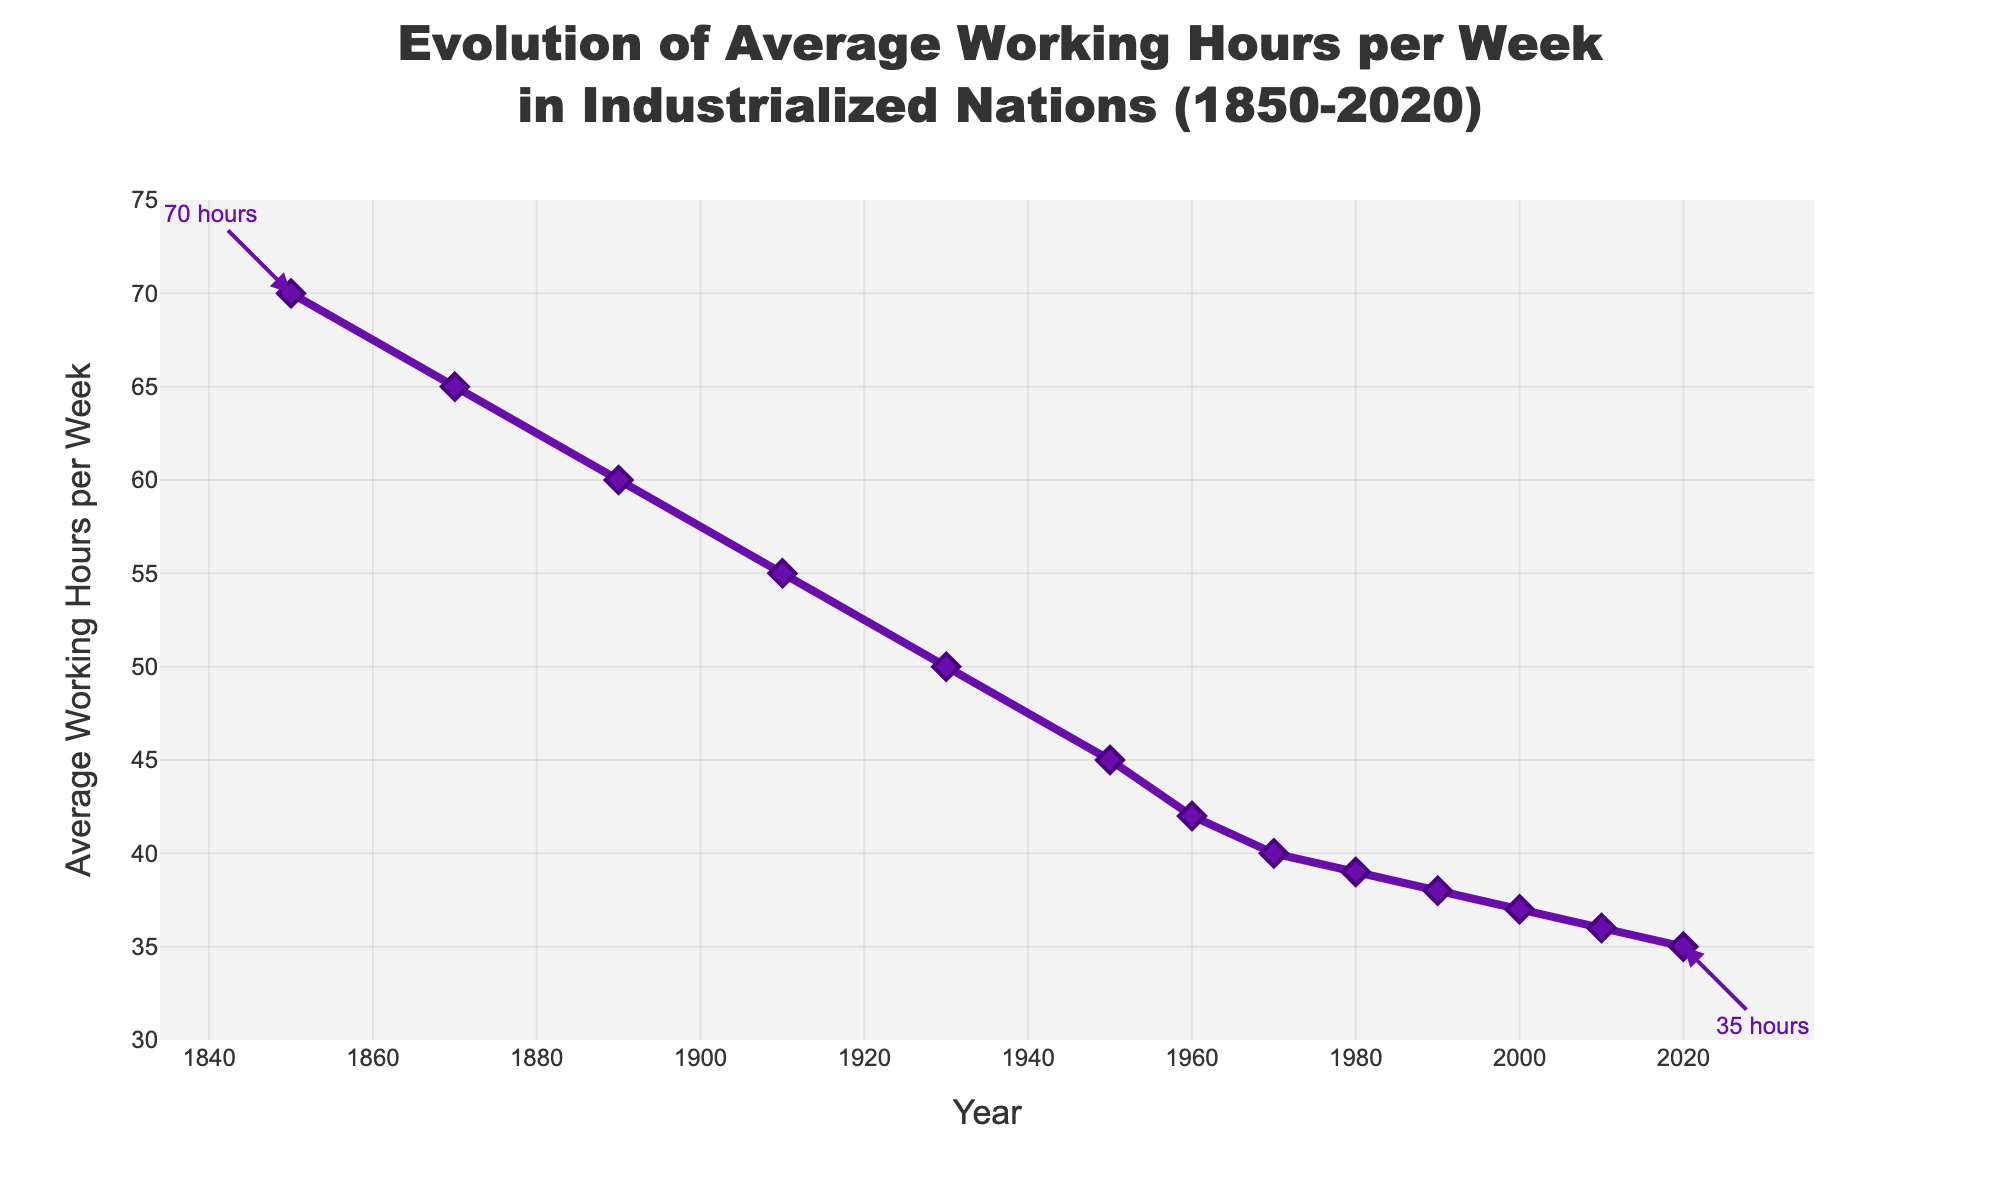When did the average working hours reach 40 hours per week? According to the plot, the average working hours per week reached 40 hours around the year 1970.
Answer: 1970 How much did the average working hours per week decrease between 1850 and 2020? In 1850, the average working hours per week were 70, and in 2020, they were 35. The decrease can be calculated as: 70 - 35 = 35 hours.
Answer: 35 hours Which period saw the largest decrease in average working hours per week: 1950 to 1970 or 1970 to 1990? From 1950 to 1970, the working hours decreased from 45 to 40 hours, a 5-hour decrease. From 1970 to 1990, the working hours decreased from 40 to 38 hours, a 2-hour decrease. Thus, the largest decrease was from 1950 to 1970.
Answer: 1950 to 1970 What is the average of average working hours per week for the years 1850, 1950, and 2020? The average can be calculated by summing the working hours of the years 1850 (70), 1950 (45), and 2020 (35) and then dividing by 3: (70 + 45 + 35) / 3 = 50 hours
Answer: 50 hours By how many hours did the average working hours decrease from 1930 to 1980? In 1930, the average working hours were 50, and in 1980, they were 39. The decrease can be calculated as: 50 - 39 = 11 hours.
Answer: 11 hours What is the average working hours per week in the year closest to the midpoint of the timeline presented? The timeline spans from 1850 to 2020, which is 170 years. The midpoint of this range is around year 1935. The closest data point is from the year 1930, where the average working hours were 50 hours.
Answer: 50 hours Is there any period where the decrease in average working hours per week slowed down or remained almost constant? Between 1970 and 1980, the average working hours remained fairly constant, decreasing only slightly from 40 to 39 hours.
Answer: 1970 to 1980 At what rate did the average working hours decrease per decade from 1850 to 1950? The average working hours decreased from 70 in 1850 to 45 in 1950, giving a total decrease of 25 hours over 100 years, or an average rate of 2.5 hours per decade.
Answer: 2.5 hours per decade What is the difference in average working hours between 1870 and 1990? In 1870, the average working hours were 65, and in 1990, they were 38. The difference can be calculated as: 65 - 38 = 27 hours.
Answer: 27 hours 